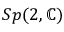Convert formula to latex. <formula><loc_0><loc_0><loc_500><loc_500>S p ( 2 , \mathbb { C } )</formula> 